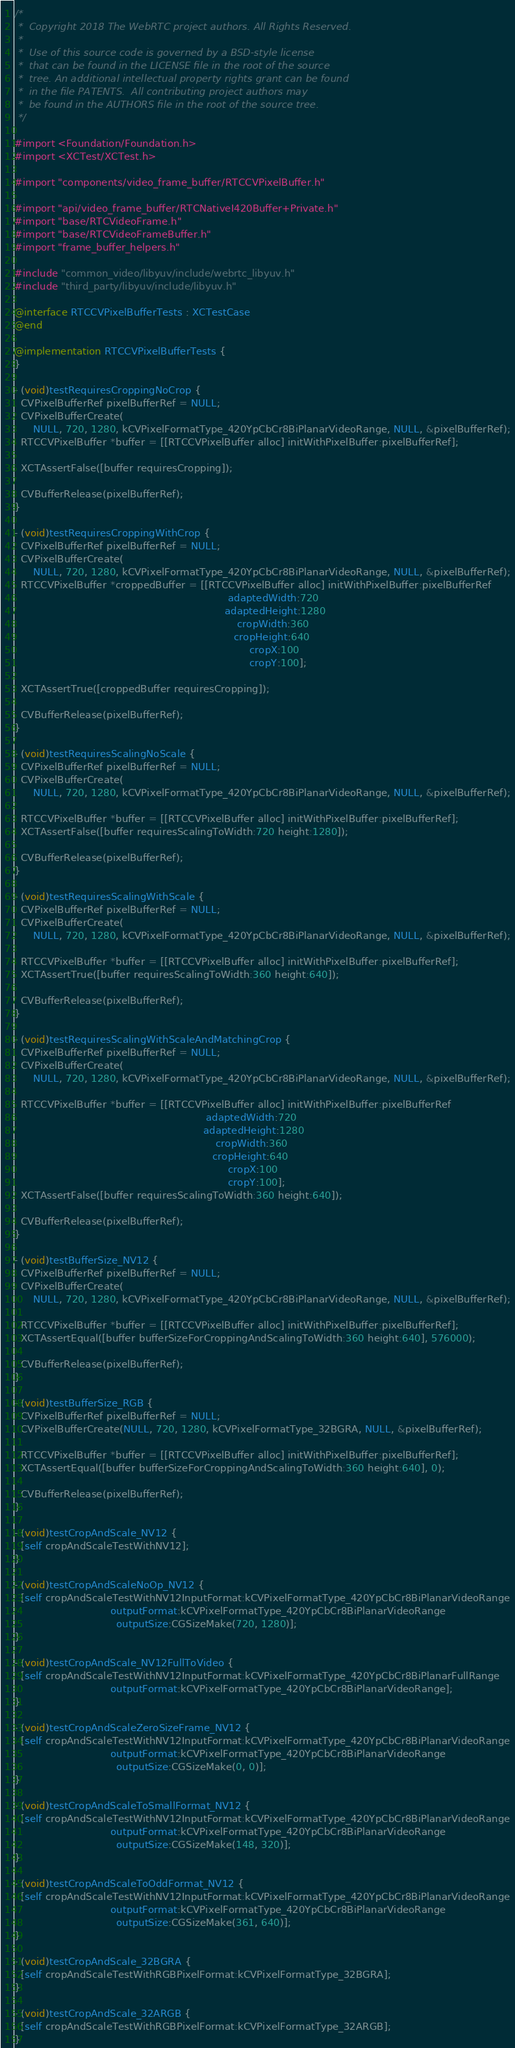Convert code to text. <code><loc_0><loc_0><loc_500><loc_500><_ObjectiveC_>/*
 *  Copyright 2018 The WebRTC project authors. All Rights Reserved.
 *
 *  Use of this source code is governed by a BSD-style license
 *  that can be found in the LICENSE file in the root of the source
 *  tree. An additional intellectual property rights grant can be found
 *  in the file PATENTS.  All contributing project authors may
 *  be found in the AUTHORS file in the root of the source tree.
 */

#import <Foundation/Foundation.h>
#import <XCTest/XCTest.h>

#import "components/video_frame_buffer/RTCCVPixelBuffer.h"

#import "api/video_frame_buffer/RTCNativeI420Buffer+Private.h"
#import "base/RTCVideoFrame.h"
#import "base/RTCVideoFrameBuffer.h"
#import "frame_buffer_helpers.h"

#include "common_video/libyuv/include/webrtc_libyuv.h"
#include "third_party/libyuv/include/libyuv.h"

@interface RTCCVPixelBufferTests : XCTestCase
@end

@implementation RTCCVPixelBufferTests {
}

- (void)testRequiresCroppingNoCrop {
  CVPixelBufferRef pixelBufferRef = NULL;
  CVPixelBufferCreate(
      NULL, 720, 1280, kCVPixelFormatType_420YpCbCr8BiPlanarVideoRange, NULL, &pixelBufferRef);
  RTCCVPixelBuffer *buffer = [[RTCCVPixelBuffer alloc] initWithPixelBuffer:pixelBufferRef];

  XCTAssertFalse([buffer requiresCropping]);

  CVBufferRelease(pixelBufferRef);
}

- (void)testRequiresCroppingWithCrop {
  CVPixelBufferRef pixelBufferRef = NULL;
  CVPixelBufferCreate(
      NULL, 720, 1280, kCVPixelFormatType_420YpCbCr8BiPlanarVideoRange, NULL, &pixelBufferRef);
  RTCCVPixelBuffer *croppedBuffer = [[RTCCVPixelBuffer alloc] initWithPixelBuffer:pixelBufferRef
                                                                     adaptedWidth:720
                                                                    adaptedHeight:1280
                                                                        cropWidth:360
                                                                       cropHeight:640
                                                                            cropX:100
                                                                            cropY:100];

  XCTAssertTrue([croppedBuffer requiresCropping]);

  CVBufferRelease(pixelBufferRef);
}

- (void)testRequiresScalingNoScale {
  CVPixelBufferRef pixelBufferRef = NULL;
  CVPixelBufferCreate(
      NULL, 720, 1280, kCVPixelFormatType_420YpCbCr8BiPlanarVideoRange, NULL, &pixelBufferRef);

  RTCCVPixelBuffer *buffer = [[RTCCVPixelBuffer alloc] initWithPixelBuffer:pixelBufferRef];
  XCTAssertFalse([buffer requiresScalingToWidth:720 height:1280]);

  CVBufferRelease(pixelBufferRef);
}

- (void)testRequiresScalingWithScale {
  CVPixelBufferRef pixelBufferRef = NULL;
  CVPixelBufferCreate(
      NULL, 720, 1280, kCVPixelFormatType_420YpCbCr8BiPlanarVideoRange, NULL, &pixelBufferRef);

  RTCCVPixelBuffer *buffer = [[RTCCVPixelBuffer alloc] initWithPixelBuffer:pixelBufferRef];
  XCTAssertTrue([buffer requiresScalingToWidth:360 height:640]);

  CVBufferRelease(pixelBufferRef);
}

- (void)testRequiresScalingWithScaleAndMatchingCrop {
  CVPixelBufferRef pixelBufferRef = NULL;
  CVPixelBufferCreate(
      NULL, 720, 1280, kCVPixelFormatType_420YpCbCr8BiPlanarVideoRange, NULL, &pixelBufferRef);

  RTCCVPixelBuffer *buffer = [[RTCCVPixelBuffer alloc] initWithPixelBuffer:pixelBufferRef
                                                              adaptedWidth:720
                                                             adaptedHeight:1280
                                                                 cropWidth:360
                                                                cropHeight:640
                                                                     cropX:100
                                                                     cropY:100];
  XCTAssertFalse([buffer requiresScalingToWidth:360 height:640]);

  CVBufferRelease(pixelBufferRef);
}

- (void)testBufferSize_NV12 {
  CVPixelBufferRef pixelBufferRef = NULL;
  CVPixelBufferCreate(
      NULL, 720, 1280, kCVPixelFormatType_420YpCbCr8BiPlanarVideoRange, NULL, &pixelBufferRef);

  RTCCVPixelBuffer *buffer = [[RTCCVPixelBuffer alloc] initWithPixelBuffer:pixelBufferRef];
  XCTAssertEqual([buffer bufferSizeForCroppingAndScalingToWidth:360 height:640], 576000);

  CVBufferRelease(pixelBufferRef);
}

- (void)testBufferSize_RGB {
  CVPixelBufferRef pixelBufferRef = NULL;
  CVPixelBufferCreate(NULL, 720, 1280, kCVPixelFormatType_32BGRA, NULL, &pixelBufferRef);

  RTCCVPixelBuffer *buffer = [[RTCCVPixelBuffer alloc] initWithPixelBuffer:pixelBufferRef];
  XCTAssertEqual([buffer bufferSizeForCroppingAndScalingToWidth:360 height:640], 0);

  CVBufferRelease(pixelBufferRef);
}

- (void)testCropAndScale_NV12 {
  [self cropAndScaleTestWithNV12];
}

- (void)testCropAndScaleNoOp_NV12 {
  [self cropAndScaleTestWithNV12InputFormat:kCVPixelFormatType_420YpCbCr8BiPlanarVideoRange
                               outputFormat:kCVPixelFormatType_420YpCbCr8BiPlanarVideoRange
                                 outputSize:CGSizeMake(720, 1280)];
}

- (void)testCropAndScale_NV12FullToVideo {
  [self cropAndScaleTestWithNV12InputFormat:kCVPixelFormatType_420YpCbCr8BiPlanarFullRange
                               outputFormat:kCVPixelFormatType_420YpCbCr8BiPlanarVideoRange];
}

- (void)testCropAndScaleZeroSizeFrame_NV12 {
  [self cropAndScaleTestWithNV12InputFormat:kCVPixelFormatType_420YpCbCr8BiPlanarVideoRange
                               outputFormat:kCVPixelFormatType_420YpCbCr8BiPlanarVideoRange
                                 outputSize:CGSizeMake(0, 0)];
}

- (void)testCropAndScaleToSmallFormat_NV12 {
  [self cropAndScaleTestWithNV12InputFormat:kCVPixelFormatType_420YpCbCr8BiPlanarVideoRange
                               outputFormat:kCVPixelFormatType_420YpCbCr8BiPlanarVideoRange
                                 outputSize:CGSizeMake(148, 320)];
}

- (void)testCropAndScaleToOddFormat_NV12 {
  [self cropAndScaleTestWithNV12InputFormat:kCVPixelFormatType_420YpCbCr8BiPlanarVideoRange
                               outputFormat:kCVPixelFormatType_420YpCbCr8BiPlanarVideoRange
                                 outputSize:CGSizeMake(361, 640)];
}

- (void)testCropAndScale_32BGRA {
  [self cropAndScaleTestWithRGBPixelFormat:kCVPixelFormatType_32BGRA];
}

- (void)testCropAndScale_32ARGB {
  [self cropAndScaleTestWithRGBPixelFormat:kCVPixelFormatType_32ARGB];
}
</code> 